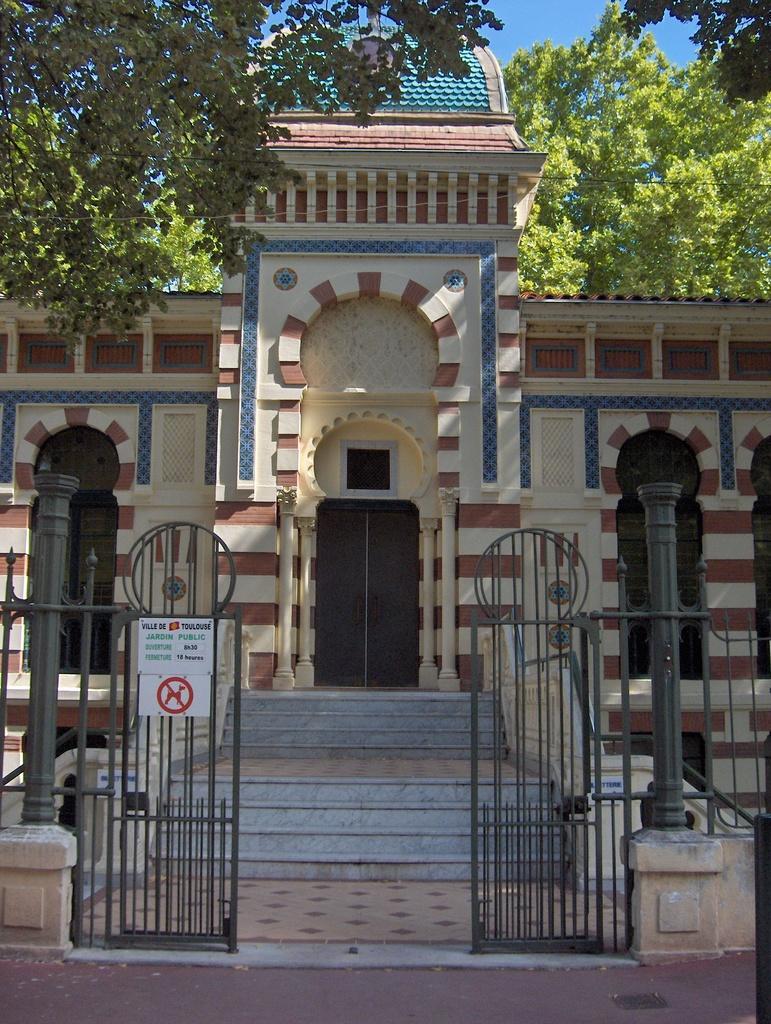Could you give a brief overview of what you see in this image? In this image I can see the building, doors, trees, gate and few boards are attached to the gate. The sky is in blue color. 